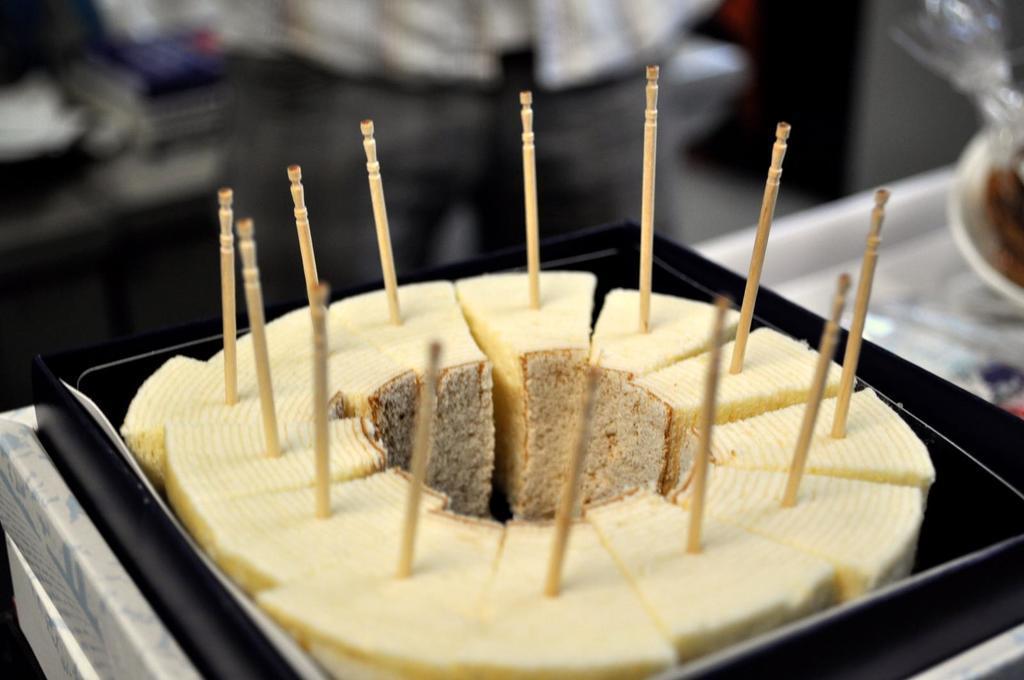Can you describe this image briefly? In this image there are pastries on the box. On top of the parties there are wooden sticks. Beside the pastries there is some object and the background of the image is blur. 